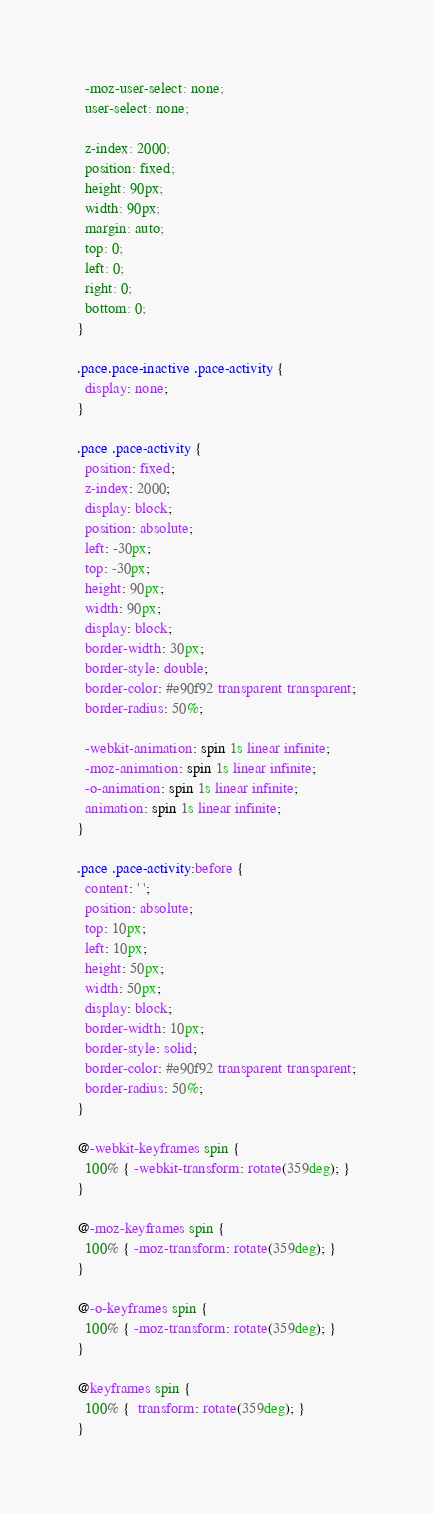<code> <loc_0><loc_0><loc_500><loc_500><_CSS_>  -moz-user-select: none;
  user-select: none;

  z-index: 2000;
  position: fixed;
  height: 90px;
  width: 90px;
  margin: auto;
  top: 0;
  left: 0;
  right: 0;
  bottom: 0;
}

.pace.pace-inactive .pace-activity {
  display: none;
}

.pace .pace-activity {
  position: fixed;
  z-index: 2000;
  display: block;
  position: absolute;
  left: -30px;
  top: -30px;
  height: 90px;
  width: 90px;
  display: block;
  border-width: 30px;
  border-style: double;
  border-color: #e90f92 transparent transparent;
  border-radius: 50%;

  -webkit-animation: spin 1s linear infinite;
  -moz-animation: spin 1s linear infinite;
  -o-animation: spin 1s linear infinite;
  animation: spin 1s linear infinite;
}

.pace .pace-activity:before {
  content: ' ';
  position: absolute;
  top: 10px;
  left: 10px;
  height: 50px;
  width: 50px;
  display: block;
  border-width: 10px;
  border-style: solid;
  border-color: #e90f92 transparent transparent;
  border-radius: 50%;
}

@-webkit-keyframes spin {
  100% { -webkit-transform: rotate(359deg); }
}

@-moz-keyframes spin {
  100% { -moz-transform: rotate(359deg); }
}

@-o-keyframes spin {
  100% { -moz-transform: rotate(359deg); }
}

@keyframes spin {
  100% {  transform: rotate(359deg); }
}
</code> 